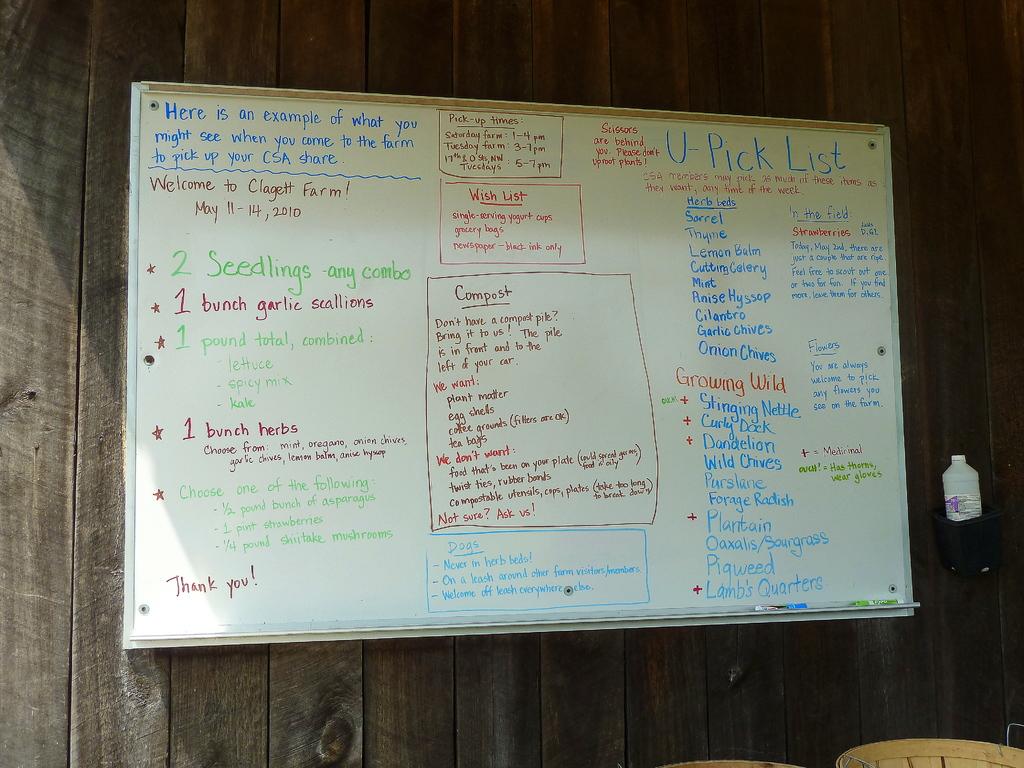How many seedlings?
Your answer should be compact. 2. 